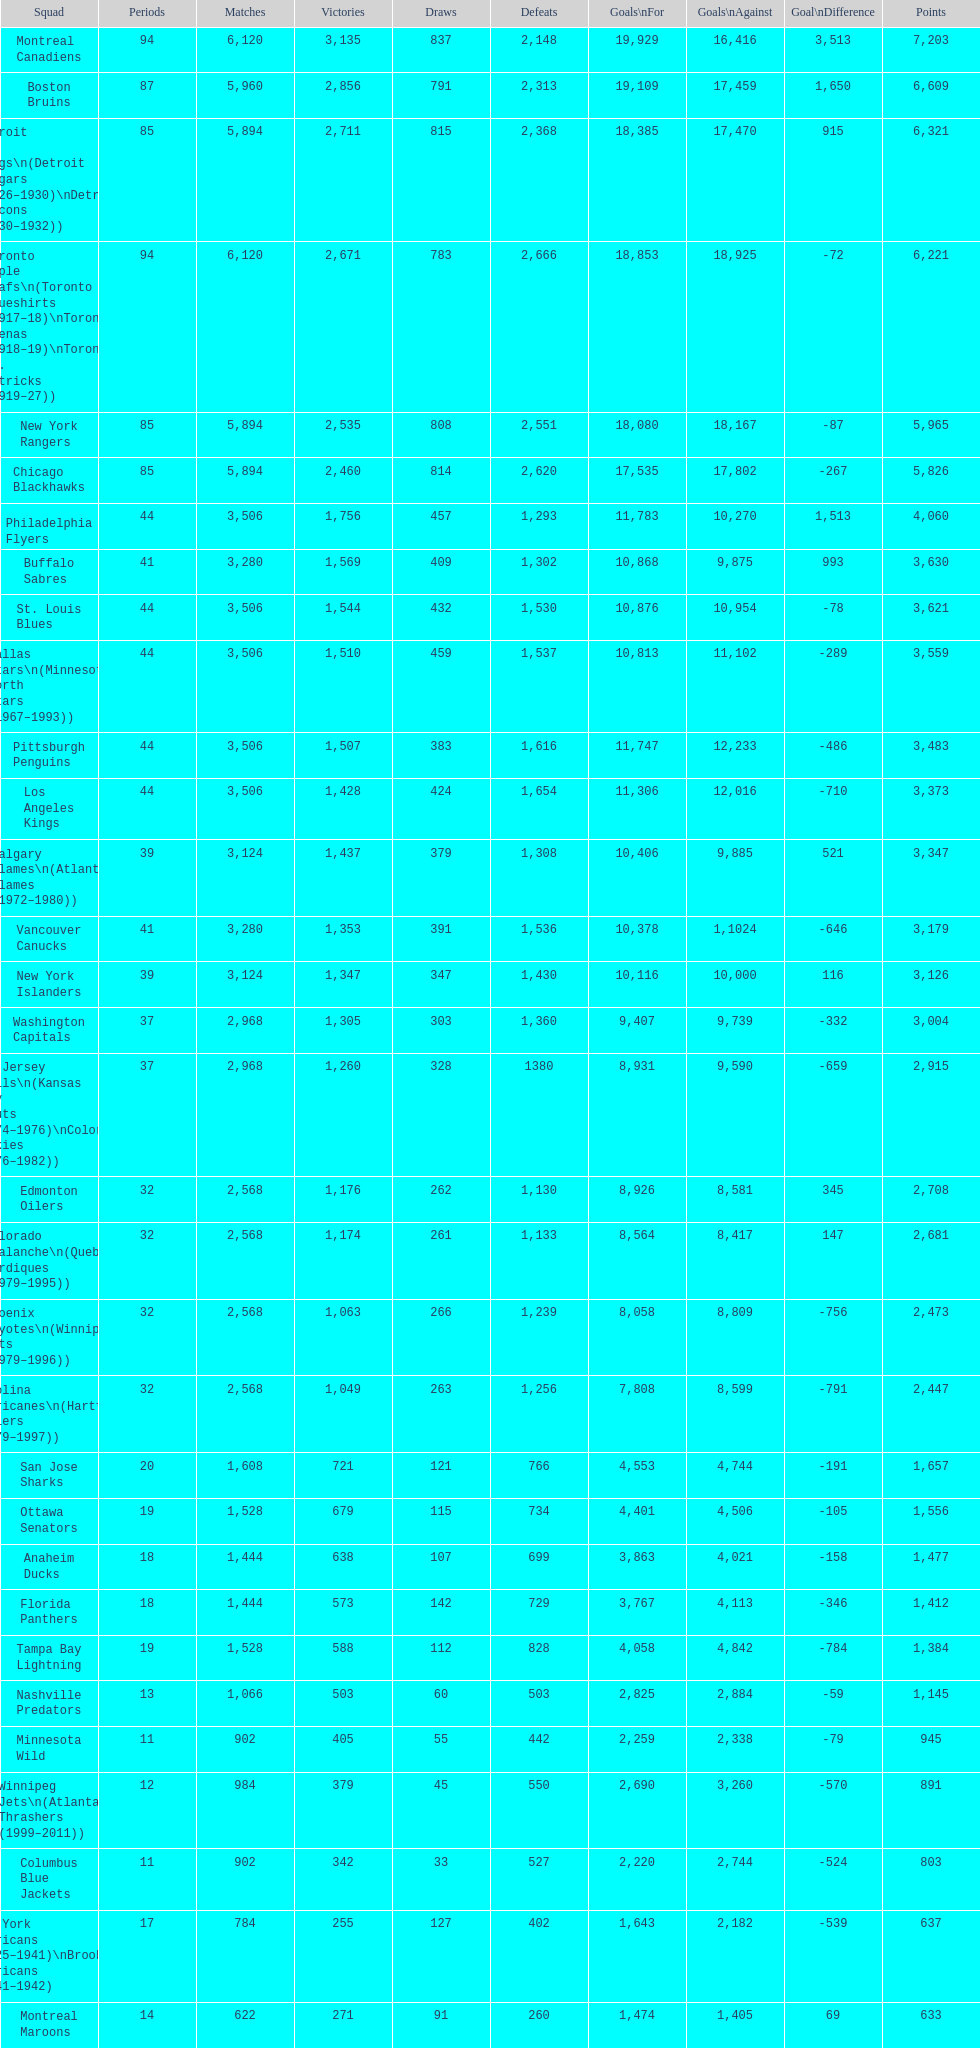Which team played the same amount of seasons as the canadiens? Toronto Maple Leafs. 